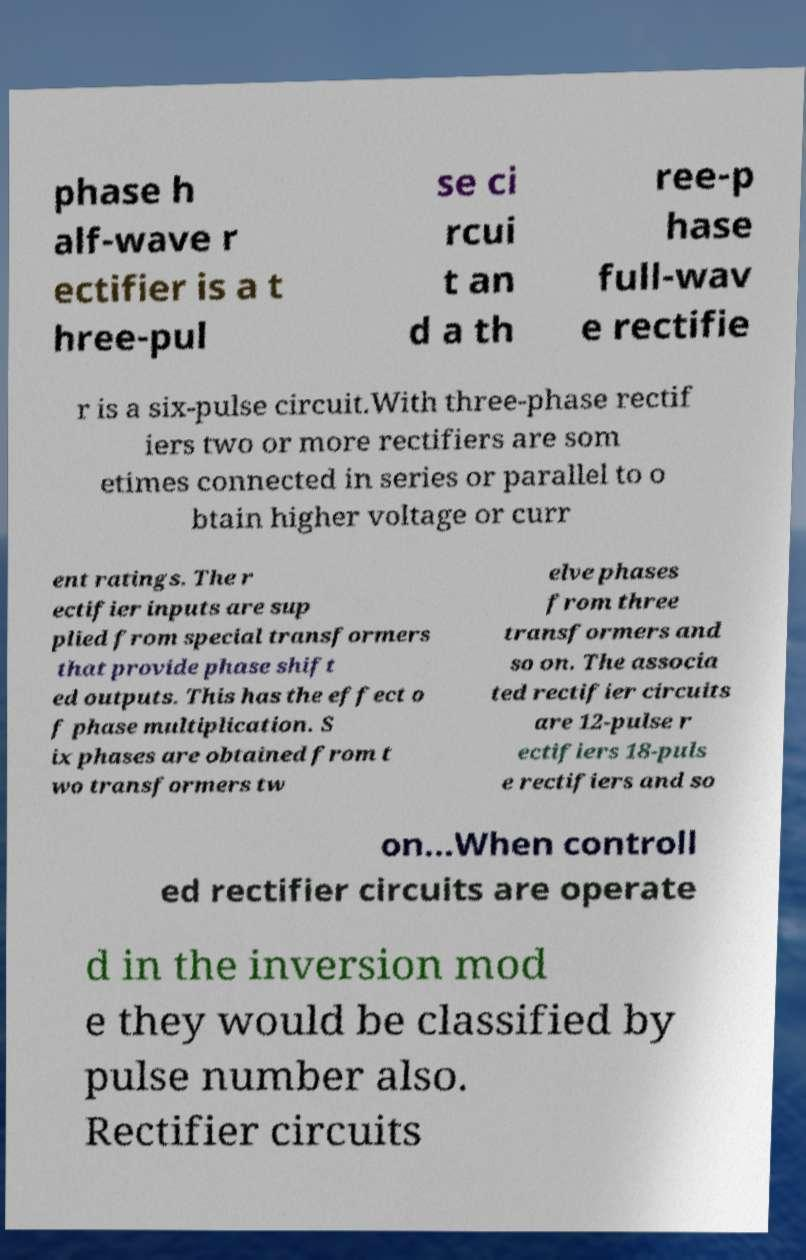Please identify and transcribe the text found in this image. phase h alf-wave r ectifier is a t hree-pul se ci rcui t an d a th ree-p hase full-wav e rectifie r is a six-pulse circuit.With three-phase rectif iers two or more rectifiers are som etimes connected in series or parallel to o btain higher voltage or curr ent ratings. The r ectifier inputs are sup plied from special transformers that provide phase shift ed outputs. This has the effect o f phase multiplication. S ix phases are obtained from t wo transformers tw elve phases from three transformers and so on. The associa ted rectifier circuits are 12-pulse r ectifiers 18-puls e rectifiers and so on...When controll ed rectifier circuits are operate d in the inversion mod e they would be classified by pulse number also. Rectifier circuits 